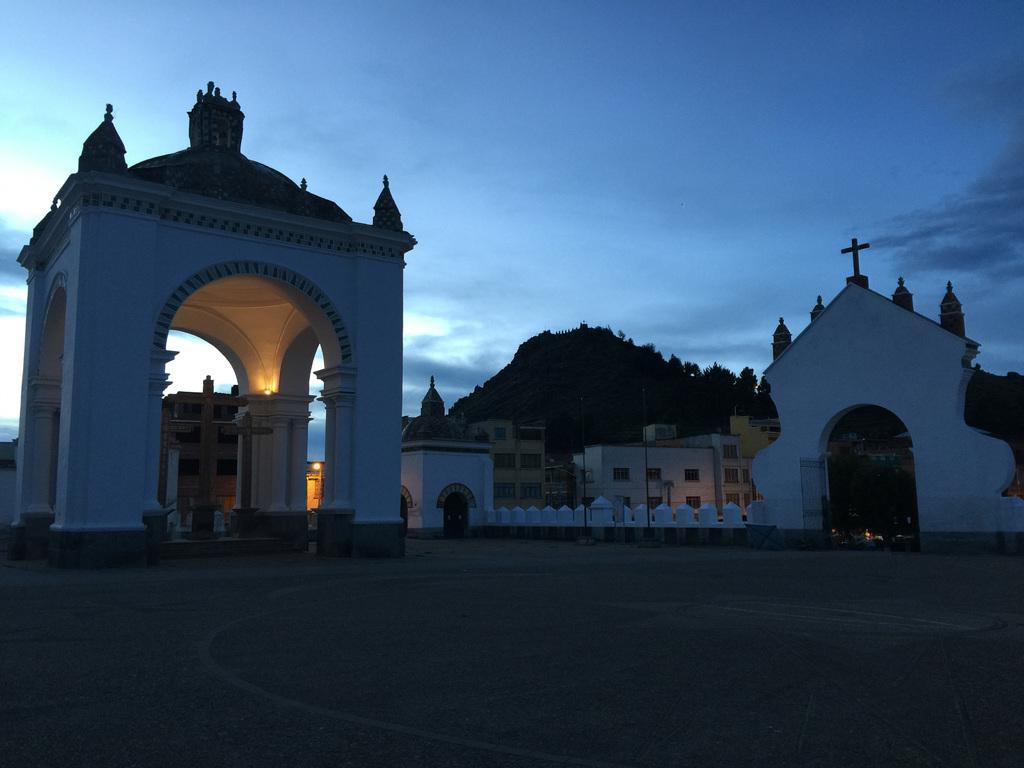Could you give a brief overview of what you see in this image? In this image there are buildings, trees, and in the background there is sky. 